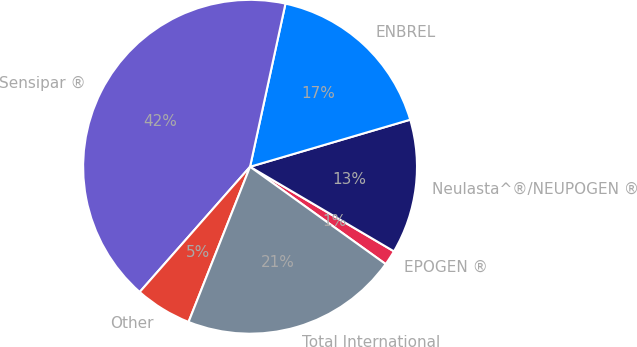Convert chart. <chart><loc_0><loc_0><loc_500><loc_500><pie_chart><fcel>EPOGEN ®<fcel>Neulasta^®/NEUPOGEN ®<fcel>ENBREL<fcel>Sensipar ®<fcel>Other<fcel>Total International<nl><fcel>1.45%<fcel>13.01%<fcel>17.05%<fcel>41.91%<fcel>5.49%<fcel>21.1%<nl></chart> 